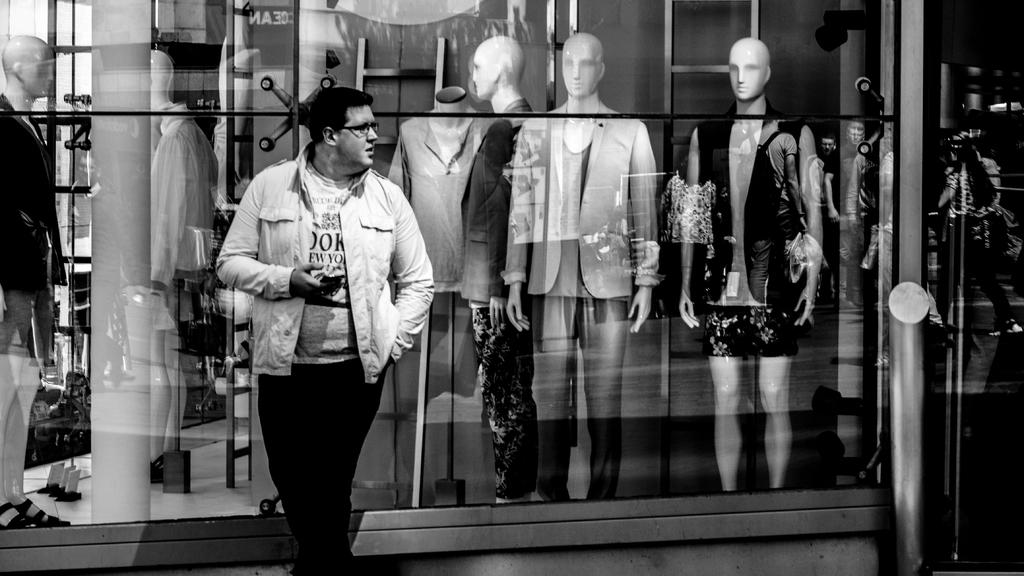What is the main subject of the image? There is a man standing in the image. What is the man doing in the image? The man is looking at something. Are there any other figures or objects in the image? Yes, there are statues of men in the image. What type of sack can be seen in the image? There is no sack present in the image. What color is the ink used to write on the trousers in the image? There are no trousers or ink present in the image. 